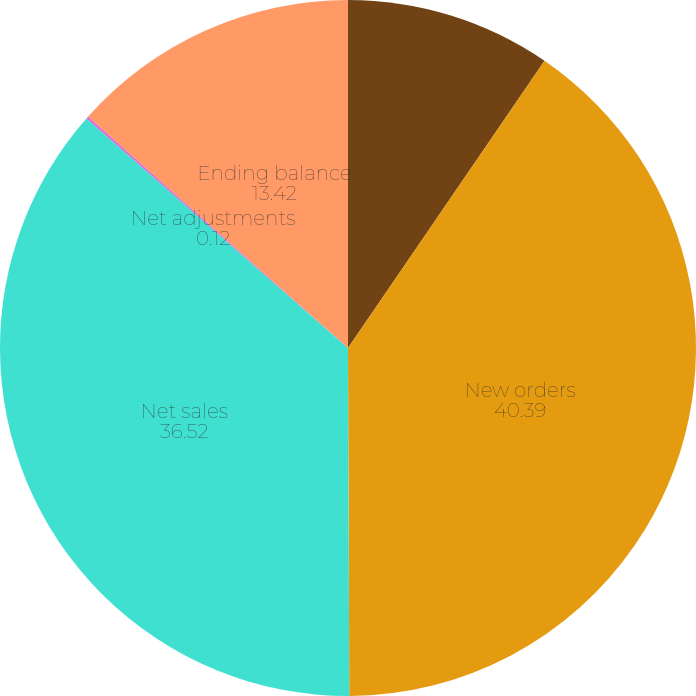Convert chart. <chart><loc_0><loc_0><loc_500><loc_500><pie_chart><fcel>Beginning balance<fcel>New orders<fcel>Net sales<fcel>Net adjustments<fcel>Ending balance<nl><fcel>9.55%<fcel>40.39%<fcel>36.52%<fcel>0.12%<fcel>13.42%<nl></chart> 